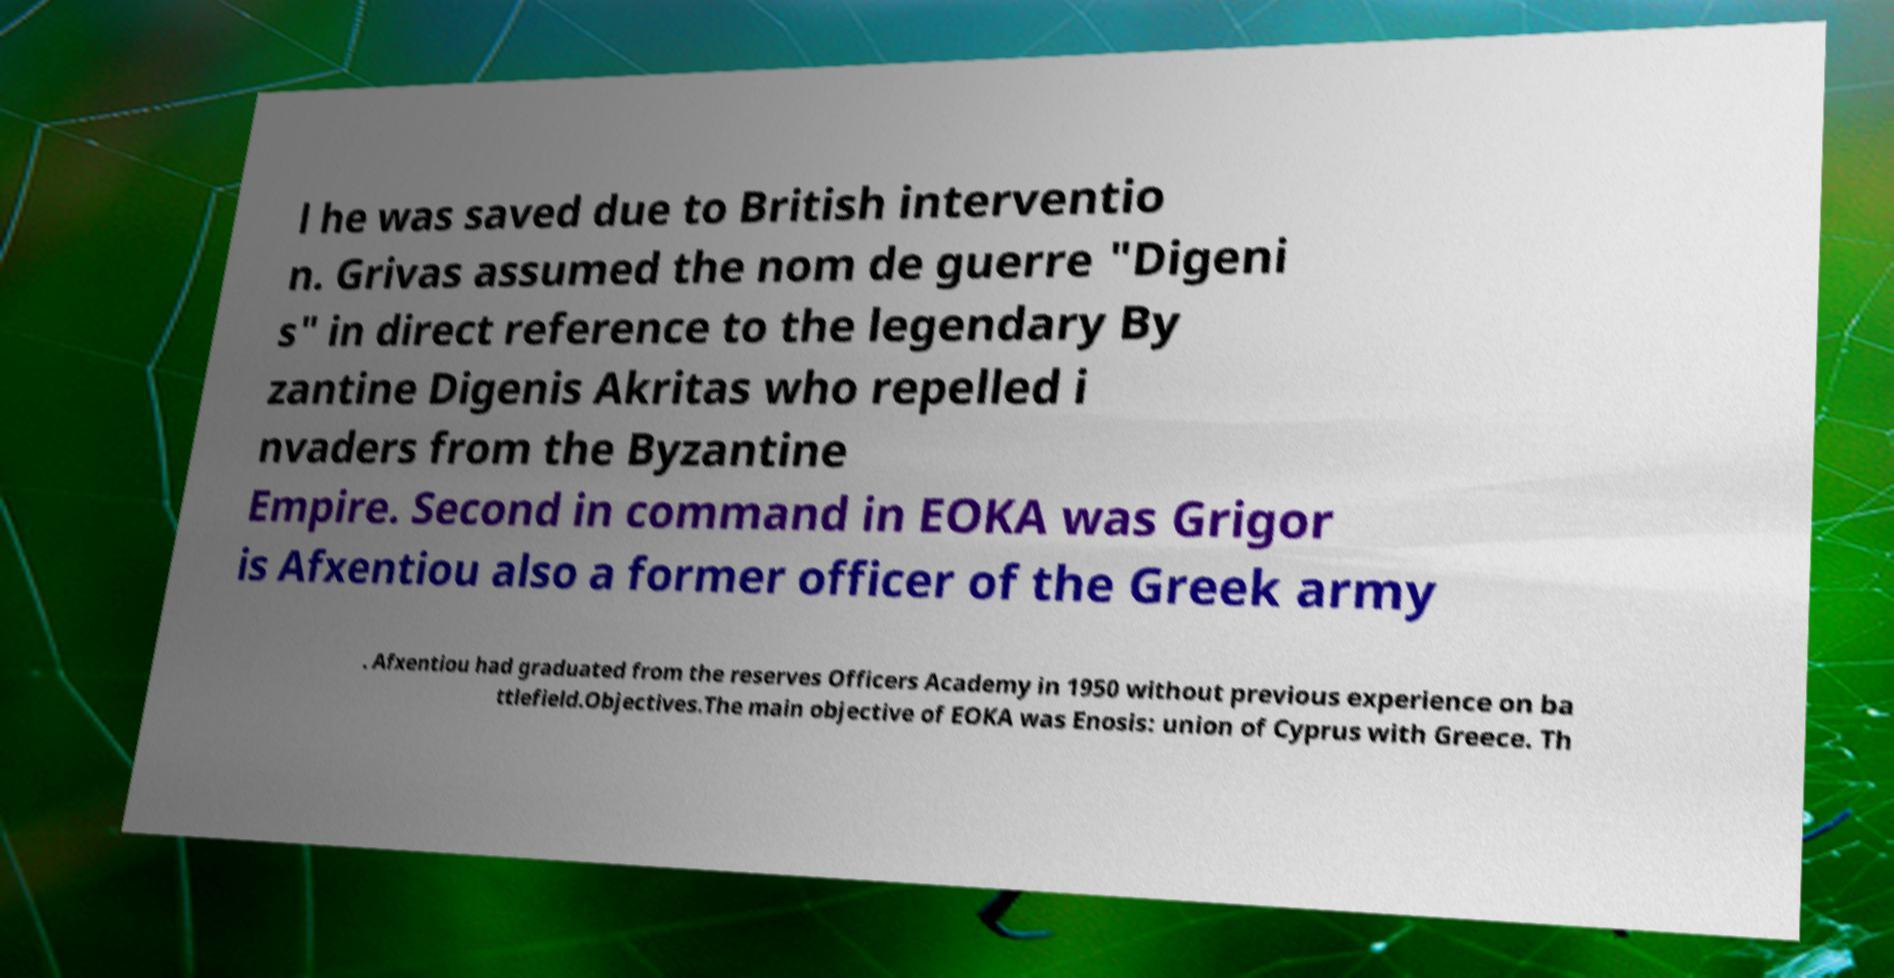For documentation purposes, I need the text within this image transcribed. Could you provide that? l he was saved due to British interventio n. Grivas assumed the nom de guerre "Digeni s" in direct reference to the legendary By zantine Digenis Akritas who repelled i nvaders from the Byzantine Empire. Second in command in EOKA was Grigor is Afxentiou also a former officer of the Greek army . Afxentiou had graduated from the reserves Officers Academy in 1950 without previous experience on ba ttlefield.Objectives.The main objective of EOKA was Enosis: union of Cyprus with Greece. Th 